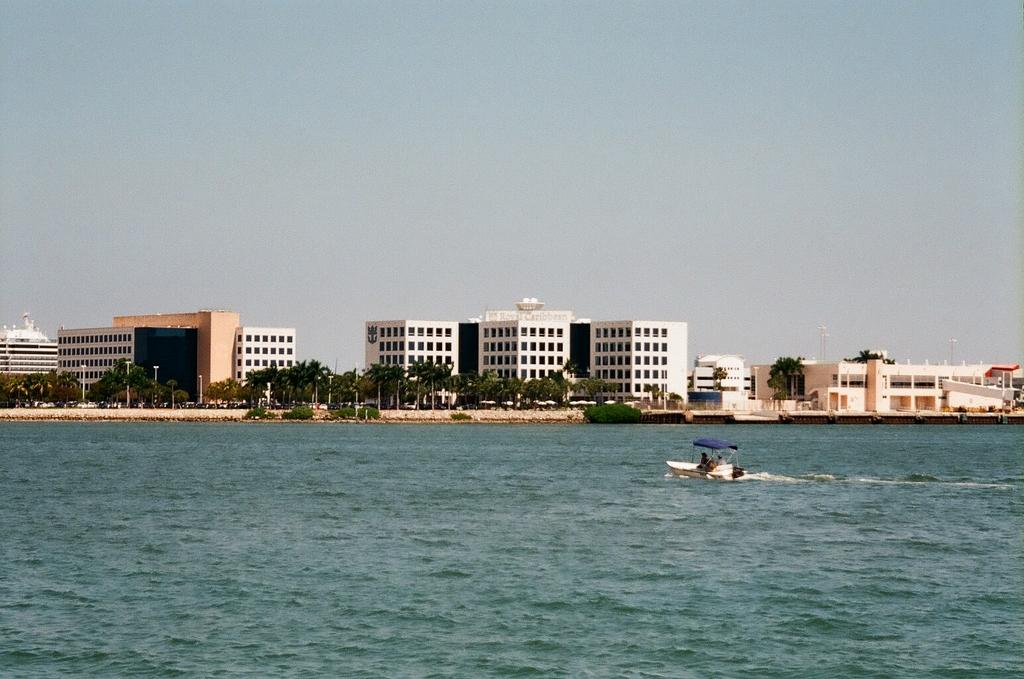What is in the water in the image? There is a boat in the water in the image. What type of structure can be seen in the image? There is a fence in the image. What type of vegetation is present in the image? There are trees in the image. What type of man-made structures are present in the image? There are light poles and buildings in the image. What type of transportation is visible in the image? There are vehicles on the road in the image. What part of the natural environment is visible in the image? The sky is visible in the image. What can be inferred about the location of the image? The image may have been taken near the ocean. What type of yoke is being used by the boat in the image? There is no yoke present in the image; the boat is likely powered by a motor or sails. What type of beam is holding up the trees in the image? There is no beam present in the image; the trees are supported by their roots and the surrounding soil. 